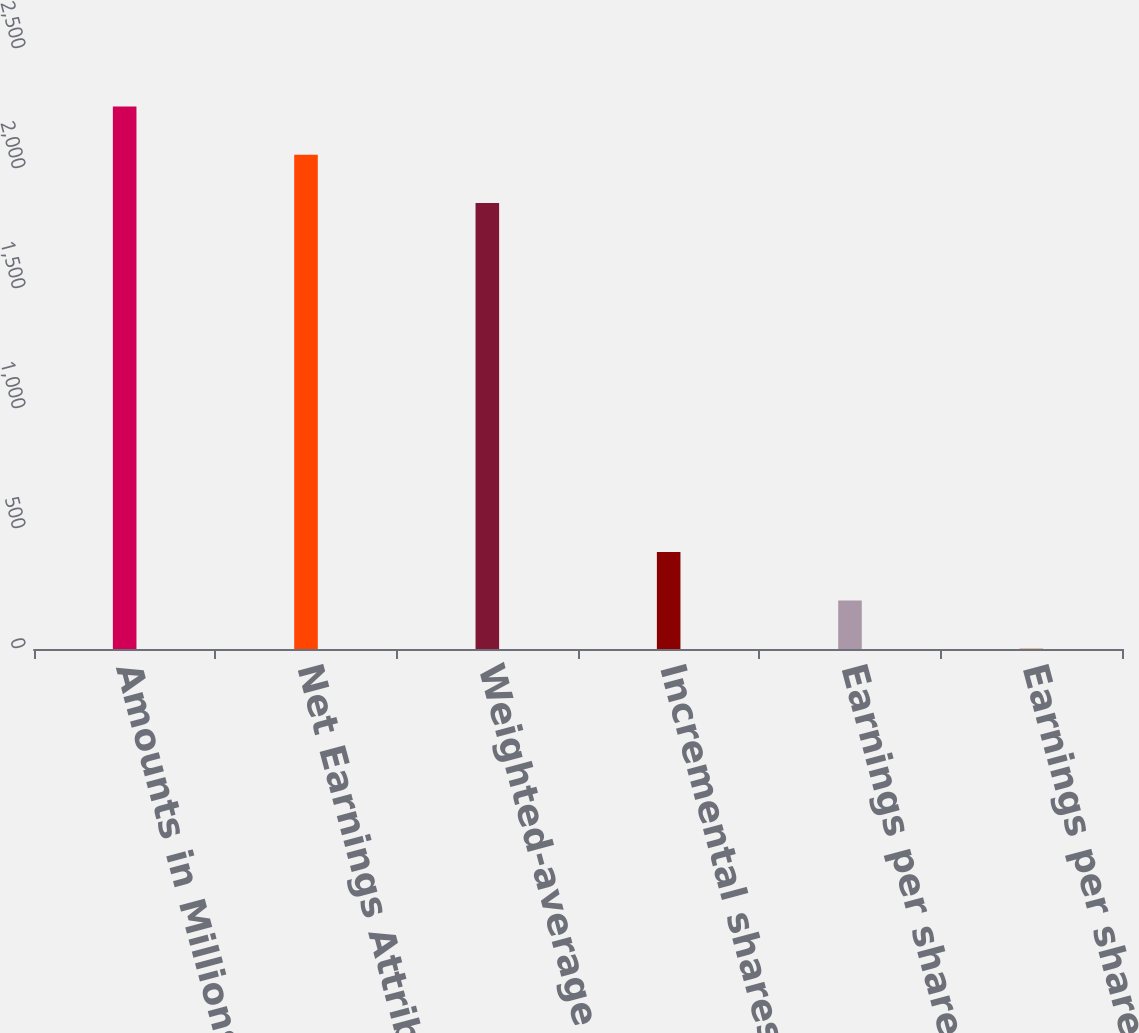Convert chart to OTSL. <chart><loc_0><loc_0><loc_500><loc_500><bar_chart><fcel>Amounts in Millions Except Per<fcel>Net Earnings Attributable to<fcel>Weighted-average common shares<fcel>Incremental shares<fcel>Earnings per share - basic<fcel>Earnings per share - diluted<nl><fcel>2260.84<fcel>2059.56<fcel>1858.28<fcel>403.76<fcel>202.48<fcel>1.2<nl></chart> 